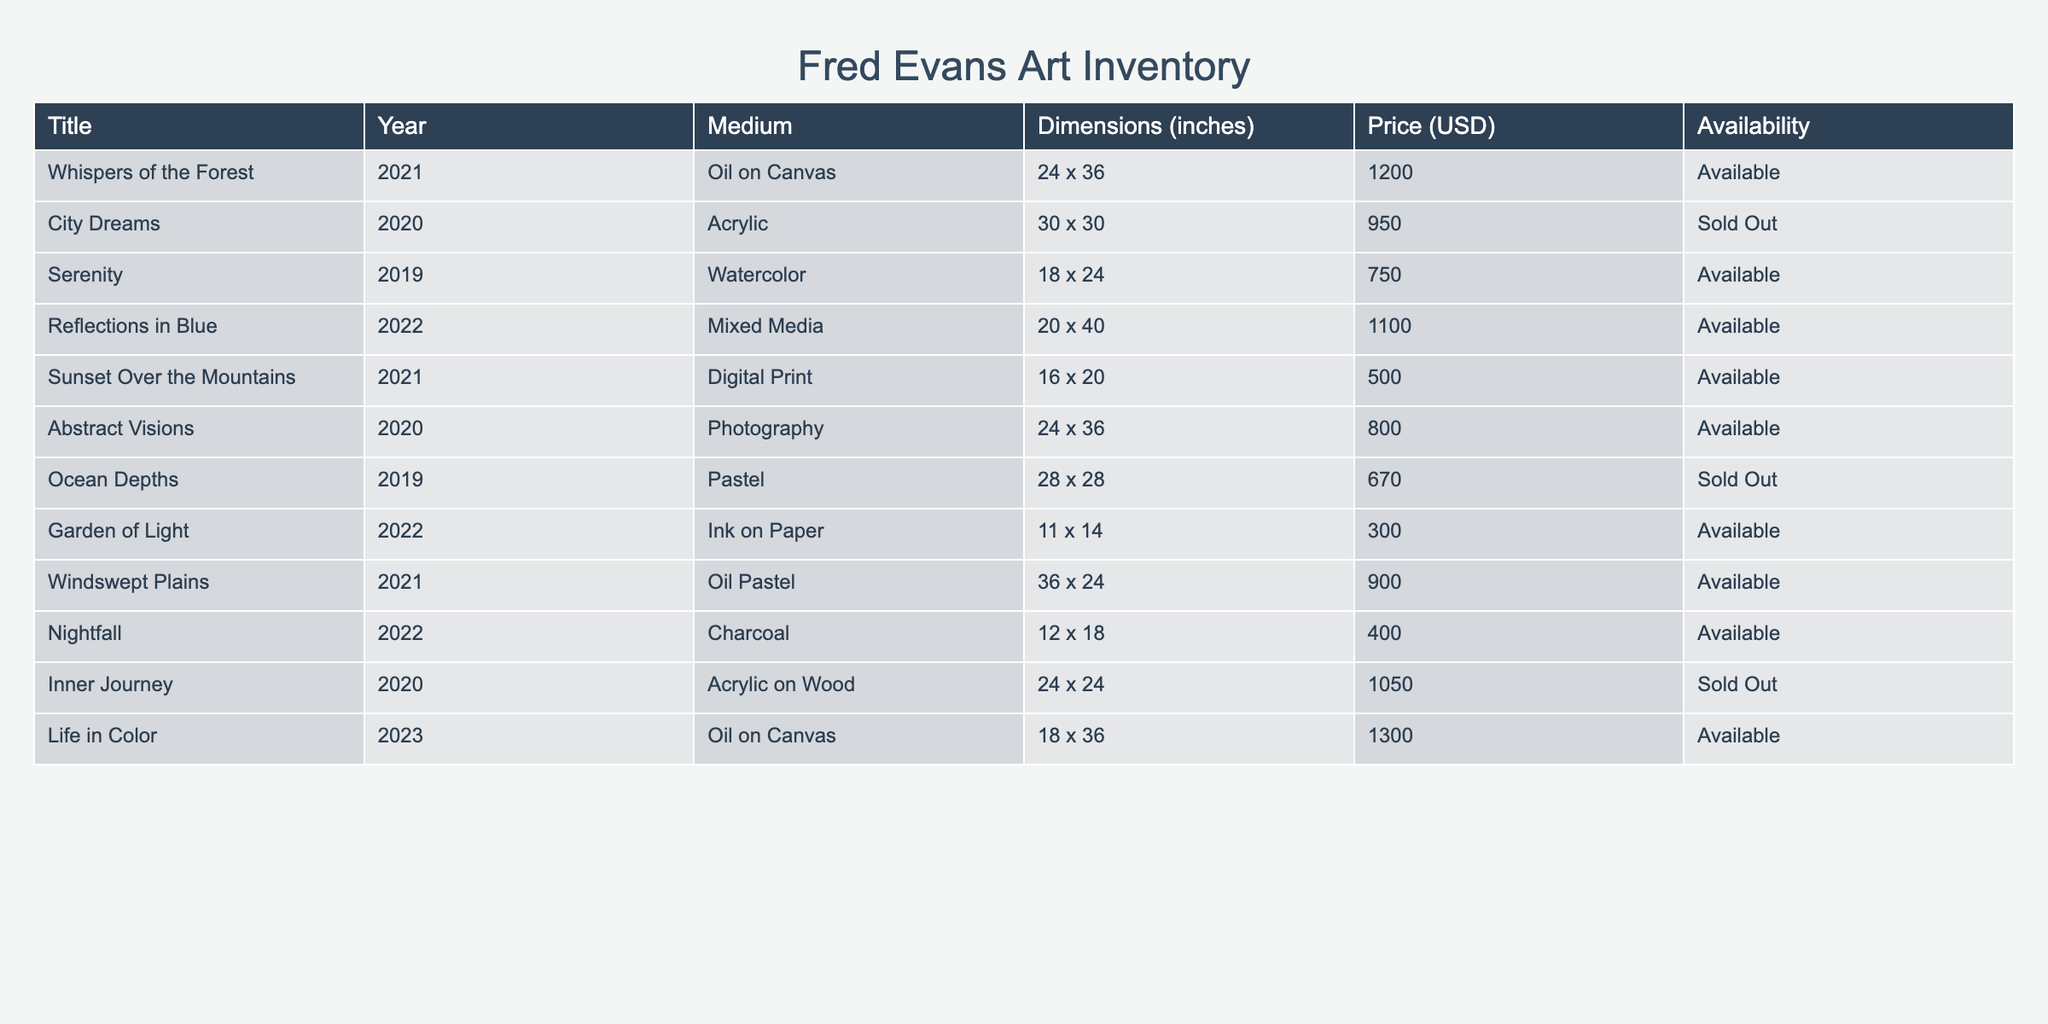What is the price of "Whispers of the Forest"? The table lists the piece "Whispers of the Forest" under the Price column, showing that it costs 1200 USD.
Answer: 1200 USD How many pieces of art are currently available for purchase? By counting the rows marked as "Available" in the Availability column, there are 7 pieces that can be purchased.
Answer: 7 Which artwork has the highest price? Comparing all prices listed, "Life in Color" at 1300 USD is the highest.
Answer: Life in Color Is "Garden of Light" sold out? The table shows that "Garden of Light" is listed as "Available".
Answer: No What is the average price of the available artwork? The available pieces are priced at 1200, 750, 1100, 500, 800, 900, and 1300. Summing these gives 4550 USD, and dividing by the 7 available pieces results in an average of approximately 650 USD.
Answer: 650 USD How many pieces are from the year 2021? The table has three pieces from 2021: "Whispers of the Forest," "Sunset Over the Mountains," and "Windswept Plains".
Answer: 3 What is the total price of all sold-out pieces? The sold-out pieces are priced at 950, 670, and 1050. Summing these prices gives 2670 USD.
Answer: 2670 USD Which medium has the most artworks available? Looking at the available artworks, both Oil on Canvas and Acrylic have 2 pieces each, while the others have either one or none, making them the most represented.
Answer: Oil on Canvas and Acrylic What is the price difference between the most expensive and least expensive available artwork? "Life in Color" is the most expensive at 1300 USD, and "Garden of Light" is the least at 300 USD. The difference is 1300 - 300 = 1000 USD.
Answer: 1000 USD Is there any artwork from the year 2018? Reviewing the years listed, there are no pieces dated from 2018.
Answer: No 